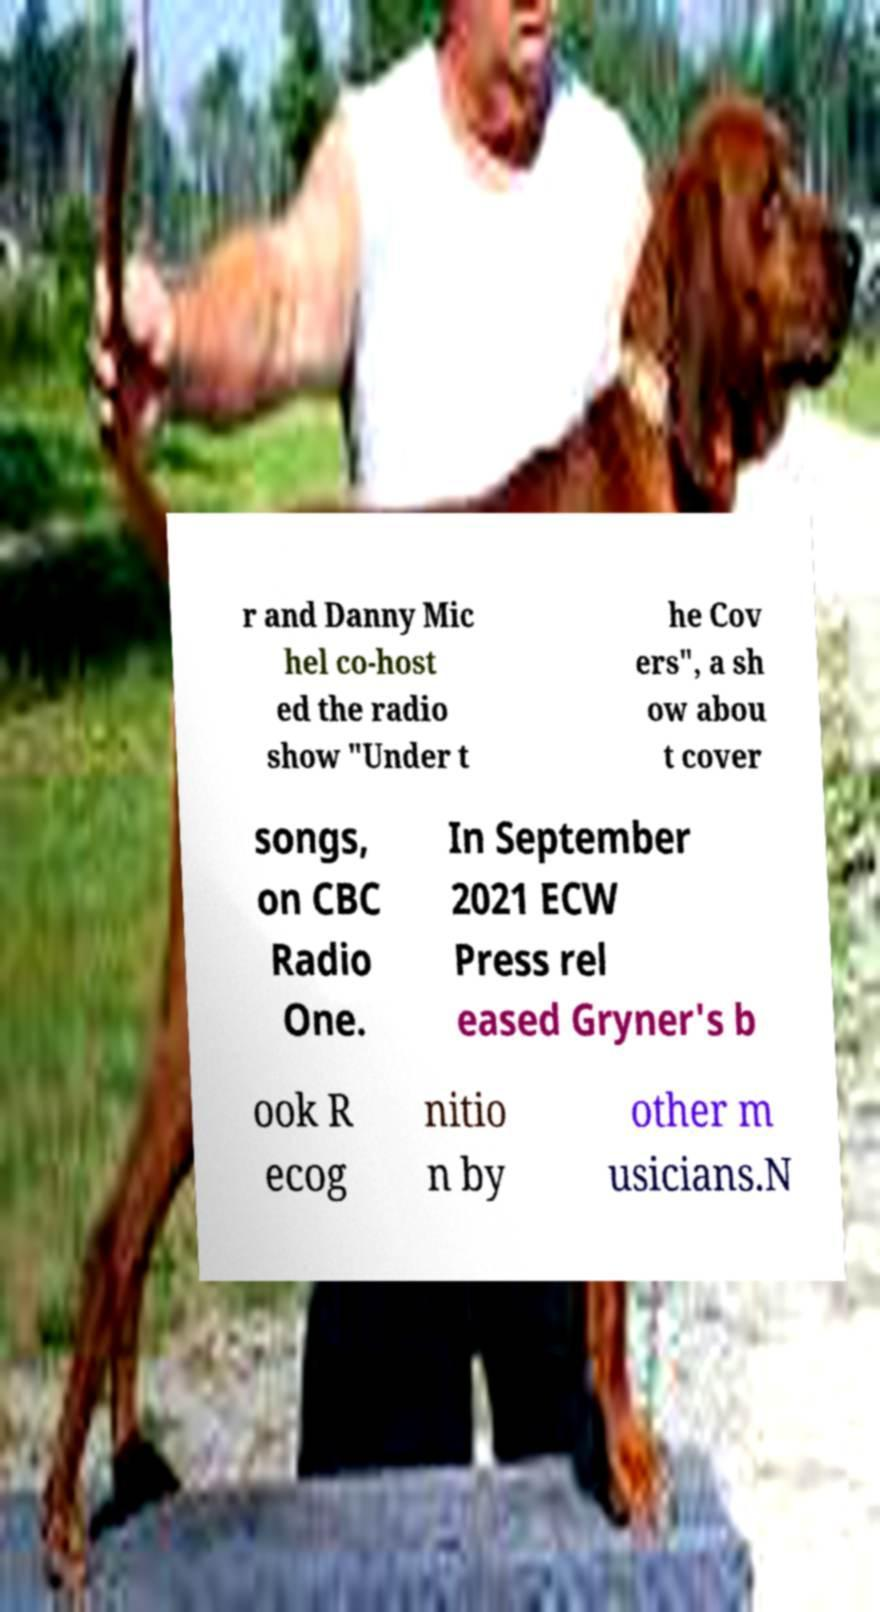I need the written content from this picture converted into text. Can you do that? r and Danny Mic hel co-host ed the radio show "Under t he Cov ers", a sh ow abou t cover songs, on CBC Radio One. In September 2021 ECW Press rel eased Gryner's b ook R ecog nitio n by other m usicians.N 